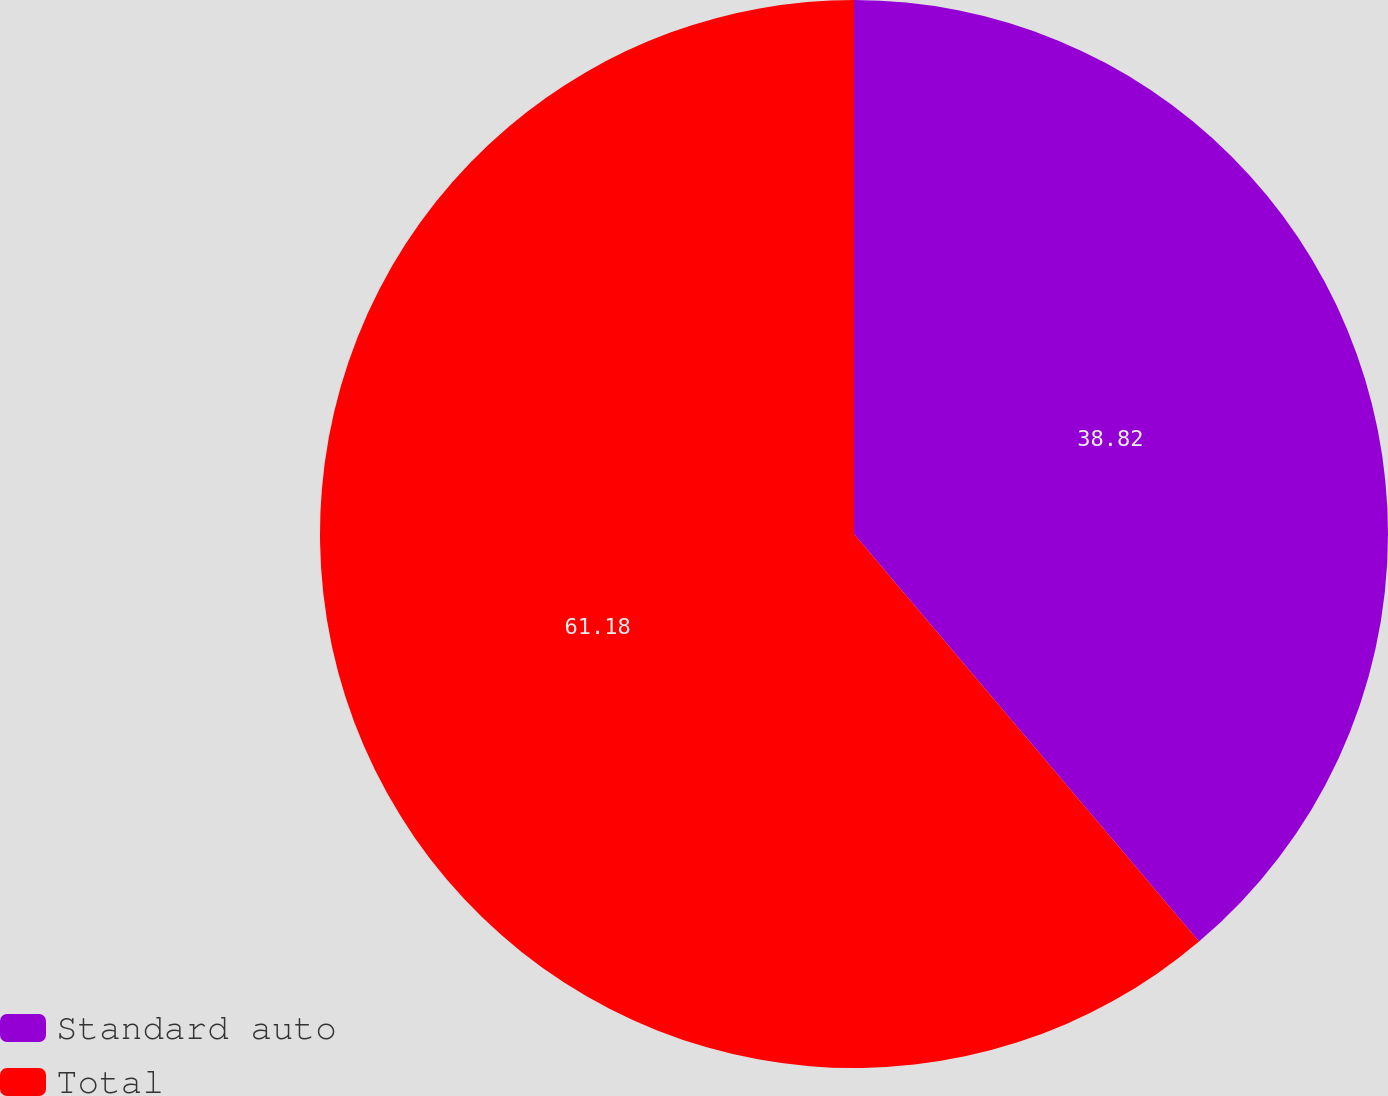Convert chart to OTSL. <chart><loc_0><loc_0><loc_500><loc_500><pie_chart><fcel>Standard auto<fcel>Total<nl><fcel>38.82%<fcel>61.18%<nl></chart> 